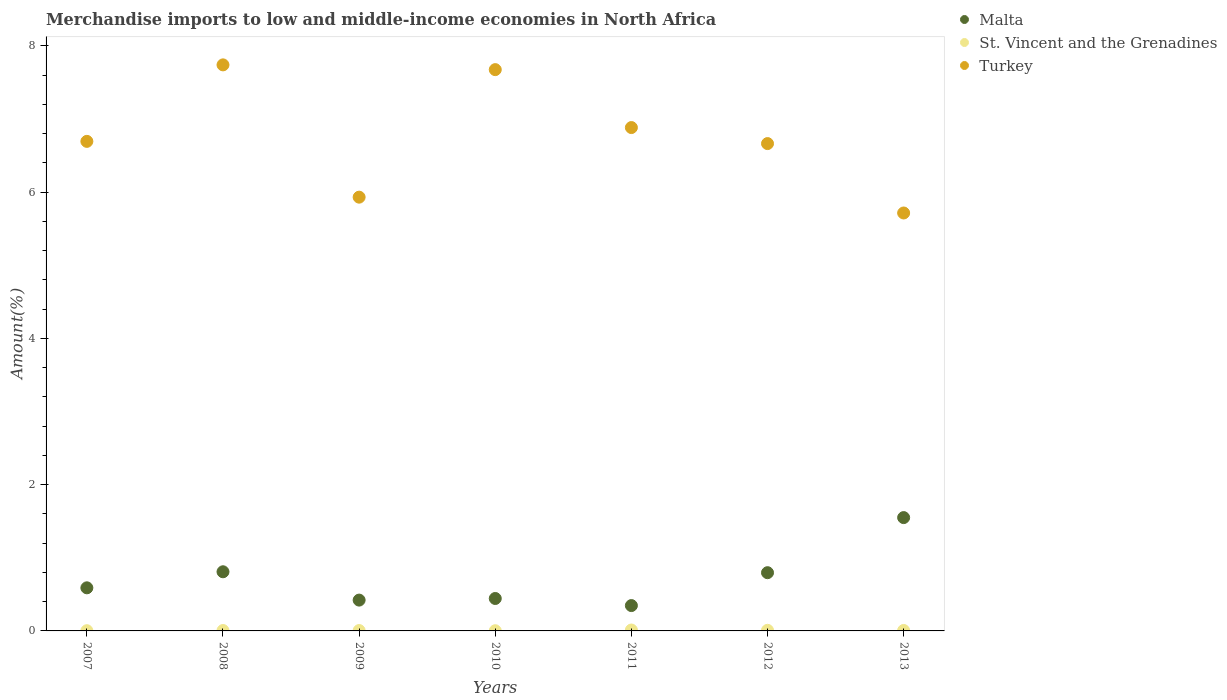How many different coloured dotlines are there?
Provide a short and direct response. 3. What is the percentage of amount earned from merchandise imports in Malta in 2010?
Make the answer very short. 0.44. Across all years, what is the maximum percentage of amount earned from merchandise imports in St. Vincent and the Grenadines?
Provide a short and direct response. 0.01. Across all years, what is the minimum percentage of amount earned from merchandise imports in Turkey?
Keep it short and to the point. 5.71. In which year was the percentage of amount earned from merchandise imports in Malta maximum?
Ensure brevity in your answer.  2013. What is the total percentage of amount earned from merchandise imports in Malta in the graph?
Provide a succinct answer. 4.96. What is the difference between the percentage of amount earned from merchandise imports in St. Vincent and the Grenadines in 2012 and that in 2013?
Make the answer very short. 0. What is the difference between the percentage of amount earned from merchandise imports in Malta in 2012 and the percentage of amount earned from merchandise imports in St. Vincent and the Grenadines in 2010?
Offer a terse response. 0.79. What is the average percentage of amount earned from merchandise imports in St. Vincent and the Grenadines per year?
Your answer should be very brief. 0.01. In the year 2013, what is the difference between the percentage of amount earned from merchandise imports in St. Vincent and the Grenadines and percentage of amount earned from merchandise imports in Malta?
Provide a succinct answer. -1.54. In how many years, is the percentage of amount earned from merchandise imports in St. Vincent and the Grenadines greater than 2.4 %?
Your answer should be very brief. 0. What is the ratio of the percentage of amount earned from merchandise imports in Turkey in 2008 to that in 2012?
Your answer should be compact. 1.16. Is the percentage of amount earned from merchandise imports in St. Vincent and the Grenadines in 2007 less than that in 2008?
Make the answer very short. Yes. Is the difference between the percentage of amount earned from merchandise imports in St. Vincent and the Grenadines in 2008 and 2012 greater than the difference between the percentage of amount earned from merchandise imports in Malta in 2008 and 2012?
Give a very brief answer. No. What is the difference between the highest and the second highest percentage of amount earned from merchandise imports in St. Vincent and the Grenadines?
Keep it short and to the point. 0. What is the difference between the highest and the lowest percentage of amount earned from merchandise imports in St. Vincent and the Grenadines?
Your answer should be very brief. 0.01. Is it the case that in every year, the sum of the percentage of amount earned from merchandise imports in Turkey and percentage of amount earned from merchandise imports in Malta  is greater than the percentage of amount earned from merchandise imports in St. Vincent and the Grenadines?
Provide a succinct answer. Yes. Is the percentage of amount earned from merchandise imports in Malta strictly greater than the percentage of amount earned from merchandise imports in St. Vincent and the Grenadines over the years?
Your answer should be very brief. Yes. How many dotlines are there?
Make the answer very short. 3. How many years are there in the graph?
Give a very brief answer. 7. What is the difference between two consecutive major ticks on the Y-axis?
Make the answer very short. 2. Does the graph contain any zero values?
Your answer should be compact. No. Does the graph contain grids?
Your response must be concise. No. What is the title of the graph?
Ensure brevity in your answer.  Merchandise imports to low and middle-income economies in North Africa. What is the label or title of the Y-axis?
Your answer should be very brief. Amount(%). What is the Amount(%) in Malta in 2007?
Ensure brevity in your answer.  0.59. What is the Amount(%) in St. Vincent and the Grenadines in 2007?
Provide a short and direct response. 0. What is the Amount(%) of Turkey in 2007?
Keep it short and to the point. 6.69. What is the Amount(%) of Malta in 2008?
Keep it short and to the point. 0.81. What is the Amount(%) of St. Vincent and the Grenadines in 2008?
Offer a terse response. 0.01. What is the Amount(%) of Turkey in 2008?
Provide a succinct answer. 7.74. What is the Amount(%) in Malta in 2009?
Keep it short and to the point. 0.42. What is the Amount(%) of St. Vincent and the Grenadines in 2009?
Offer a terse response. 0.01. What is the Amount(%) in Turkey in 2009?
Offer a very short reply. 5.93. What is the Amount(%) of Malta in 2010?
Ensure brevity in your answer.  0.44. What is the Amount(%) in St. Vincent and the Grenadines in 2010?
Offer a very short reply. 0. What is the Amount(%) of Turkey in 2010?
Give a very brief answer. 7.68. What is the Amount(%) of Malta in 2011?
Offer a terse response. 0.35. What is the Amount(%) of St. Vincent and the Grenadines in 2011?
Your answer should be compact. 0.01. What is the Amount(%) in Turkey in 2011?
Offer a very short reply. 6.88. What is the Amount(%) in Malta in 2012?
Your response must be concise. 0.8. What is the Amount(%) in St. Vincent and the Grenadines in 2012?
Provide a succinct answer. 0.01. What is the Amount(%) in Turkey in 2012?
Provide a short and direct response. 6.66. What is the Amount(%) of Malta in 2013?
Your answer should be very brief. 1.55. What is the Amount(%) of St. Vincent and the Grenadines in 2013?
Your answer should be compact. 0.01. What is the Amount(%) of Turkey in 2013?
Your answer should be very brief. 5.71. Across all years, what is the maximum Amount(%) of Malta?
Your answer should be compact. 1.55. Across all years, what is the maximum Amount(%) of St. Vincent and the Grenadines?
Make the answer very short. 0.01. Across all years, what is the maximum Amount(%) in Turkey?
Your answer should be very brief. 7.74. Across all years, what is the minimum Amount(%) of Malta?
Provide a short and direct response. 0.35. Across all years, what is the minimum Amount(%) of St. Vincent and the Grenadines?
Your response must be concise. 0. Across all years, what is the minimum Amount(%) of Turkey?
Provide a succinct answer. 5.71. What is the total Amount(%) of Malta in the graph?
Make the answer very short. 4.96. What is the total Amount(%) in St. Vincent and the Grenadines in the graph?
Make the answer very short. 0.04. What is the total Amount(%) of Turkey in the graph?
Your answer should be compact. 47.3. What is the difference between the Amount(%) of Malta in 2007 and that in 2008?
Keep it short and to the point. -0.22. What is the difference between the Amount(%) of St. Vincent and the Grenadines in 2007 and that in 2008?
Provide a short and direct response. -0. What is the difference between the Amount(%) of Turkey in 2007 and that in 2008?
Keep it short and to the point. -1.05. What is the difference between the Amount(%) in Malta in 2007 and that in 2009?
Offer a very short reply. 0.17. What is the difference between the Amount(%) in St. Vincent and the Grenadines in 2007 and that in 2009?
Offer a terse response. -0. What is the difference between the Amount(%) in Turkey in 2007 and that in 2009?
Offer a very short reply. 0.76. What is the difference between the Amount(%) in Malta in 2007 and that in 2010?
Offer a terse response. 0.15. What is the difference between the Amount(%) of St. Vincent and the Grenadines in 2007 and that in 2010?
Offer a very short reply. 0. What is the difference between the Amount(%) in Turkey in 2007 and that in 2010?
Provide a succinct answer. -0.98. What is the difference between the Amount(%) of Malta in 2007 and that in 2011?
Ensure brevity in your answer.  0.24. What is the difference between the Amount(%) in St. Vincent and the Grenadines in 2007 and that in 2011?
Give a very brief answer. -0.01. What is the difference between the Amount(%) of Turkey in 2007 and that in 2011?
Your answer should be compact. -0.19. What is the difference between the Amount(%) of Malta in 2007 and that in 2012?
Your answer should be very brief. -0.21. What is the difference between the Amount(%) of St. Vincent and the Grenadines in 2007 and that in 2012?
Your answer should be very brief. -0.01. What is the difference between the Amount(%) of Turkey in 2007 and that in 2012?
Your answer should be compact. 0.03. What is the difference between the Amount(%) of Malta in 2007 and that in 2013?
Make the answer very short. -0.96. What is the difference between the Amount(%) in St. Vincent and the Grenadines in 2007 and that in 2013?
Your answer should be very brief. -0. What is the difference between the Amount(%) of Turkey in 2007 and that in 2013?
Keep it short and to the point. 0.98. What is the difference between the Amount(%) of Malta in 2008 and that in 2009?
Provide a short and direct response. 0.39. What is the difference between the Amount(%) in St. Vincent and the Grenadines in 2008 and that in 2009?
Your answer should be very brief. 0. What is the difference between the Amount(%) in Turkey in 2008 and that in 2009?
Provide a short and direct response. 1.81. What is the difference between the Amount(%) of Malta in 2008 and that in 2010?
Provide a succinct answer. 0.37. What is the difference between the Amount(%) of St. Vincent and the Grenadines in 2008 and that in 2010?
Offer a very short reply. 0. What is the difference between the Amount(%) in Turkey in 2008 and that in 2010?
Make the answer very short. 0.07. What is the difference between the Amount(%) in Malta in 2008 and that in 2011?
Offer a terse response. 0.46. What is the difference between the Amount(%) of St. Vincent and the Grenadines in 2008 and that in 2011?
Provide a succinct answer. -0.01. What is the difference between the Amount(%) of Turkey in 2008 and that in 2011?
Your answer should be compact. 0.86. What is the difference between the Amount(%) of Malta in 2008 and that in 2012?
Make the answer very short. 0.01. What is the difference between the Amount(%) in St. Vincent and the Grenadines in 2008 and that in 2012?
Provide a short and direct response. -0. What is the difference between the Amount(%) in Turkey in 2008 and that in 2012?
Offer a very short reply. 1.08. What is the difference between the Amount(%) of Malta in 2008 and that in 2013?
Your answer should be compact. -0.74. What is the difference between the Amount(%) in St. Vincent and the Grenadines in 2008 and that in 2013?
Provide a short and direct response. -0. What is the difference between the Amount(%) in Turkey in 2008 and that in 2013?
Provide a short and direct response. 2.03. What is the difference between the Amount(%) in Malta in 2009 and that in 2010?
Your answer should be very brief. -0.02. What is the difference between the Amount(%) in St. Vincent and the Grenadines in 2009 and that in 2010?
Provide a succinct answer. 0. What is the difference between the Amount(%) in Turkey in 2009 and that in 2010?
Offer a terse response. -1.74. What is the difference between the Amount(%) of Malta in 2009 and that in 2011?
Keep it short and to the point. 0.07. What is the difference between the Amount(%) in St. Vincent and the Grenadines in 2009 and that in 2011?
Your answer should be compact. -0.01. What is the difference between the Amount(%) in Turkey in 2009 and that in 2011?
Provide a short and direct response. -0.95. What is the difference between the Amount(%) of Malta in 2009 and that in 2012?
Your response must be concise. -0.37. What is the difference between the Amount(%) of St. Vincent and the Grenadines in 2009 and that in 2012?
Give a very brief answer. -0. What is the difference between the Amount(%) of Turkey in 2009 and that in 2012?
Your answer should be very brief. -0.73. What is the difference between the Amount(%) in Malta in 2009 and that in 2013?
Offer a terse response. -1.13. What is the difference between the Amount(%) of St. Vincent and the Grenadines in 2009 and that in 2013?
Provide a short and direct response. -0. What is the difference between the Amount(%) in Turkey in 2009 and that in 2013?
Offer a terse response. 0.22. What is the difference between the Amount(%) in Malta in 2010 and that in 2011?
Make the answer very short. 0.1. What is the difference between the Amount(%) in St. Vincent and the Grenadines in 2010 and that in 2011?
Offer a very short reply. -0.01. What is the difference between the Amount(%) of Turkey in 2010 and that in 2011?
Your answer should be compact. 0.79. What is the difference between the Amount(%) in Malta in 2010 and that in 2012?
Ensure brevity in your answer.  -0.35. What is the difference between the Amount(%) of St. Vincent and the Grenadines in 2010 and that in 2012?
Your answer should be compact. -0.01. What is the difference between the Amount(%) in Turkey in 2010 and that in 2012?
Provide a succinct answer. 1.01. What is the difference between the Amount(%) in Malta in 2010 and that in 2013?
Give a very brief answer. -1.11. What is the difference between the Amount(%) in St. Vincent and the Grenadines in 2010 and that in 2013?
Give a very brief answer. -0. What is the difference between the Amount(%) in Turkey in 2010 and that in 2013?
Offer a very short reply. 1.96. What is the difference between the Amount(%) in Malta in 2011 and that in 2012?
Your response must be concise. -0.45. What is the difference between the Amount(%) in St. Vincent and the Grenadines in 2011 and that in 2012?
Your answer should be compact. 0. What is the difference between the Amount(%) of Turkey in 2011 and that in 2012?
Offer a terse response. 0.22. What is the difference between the Amount(%) of Malta in 2011 and that in 2013?
Ensure brevity in your answer.  -1.2. What is the difference between the Amount(%) in St. Vincent and the Grenadines in 2011 and that in 2013?
Ensure brevity in your answer.  0.01. What is the difference between the Amount(%) of Turkey in 2011 and that in 2013?
Offer a very short reply. 1.17. What is the difference between the Amount(%) in Malta in 2012 and that in 2013?
Provide a short and direct response. -0.75. What is the difference between the Amount(%) in St. Vincent and the Grenadines in 2012 and that in 2013?
Provide a succinct answer. 0. What is the difference between the Amount(%) of Turkey in 2012 and that in 2013?
Your answer should be compact. 0.95. What is the difference between the Amount(%) in Malta in 2007 and the Amount(%) in St. Vincent and the Grenadines in 2008?
Offer a very short reply. 0.58. What is the difference between the Amount(%) in Malta in 2007 and the Amount(%) in Turkey in 2008?
Offer a terse response. -7.15. What is the difference between the Amount(%) of St. Vincent and the Grenadines in 2007 and the Amount(%) of Turkey in 2008?
Offer a terse response. -7.74. What is the difference between the Amount(%) in Malta in 2007 and the Amount(%) in St. Vincent and the Grenadines in 2009?
Make the answer very short. 0.58. What is the difference between the Amount(%) of Malta in 2007 and the Amount(%) of Turkey in 2009?
Keep it short and to the point. -5.34. What is the difference between the Amount(%) of St. Vincent and the Grenadines in 2007 and the Amount(%) of Turkey in 2009?
Your answer should be very brief. -5.93. What is the difference between the Amount(%) in Malta in 2007 and the Amount(%) in St. Vincent and the Grenadines in 2010?
Your response must be concise. 0.59. What is the difference between the Amount(%) of Malta in 2007 and the Amount(%) of Turkey in 2010?
Offer a very short reply. -7.09. What is the difference between the Amount(%) of St. Vincent and the Grenadines in 2007 and the Amount(%) of Turkey in 2010?
Keep it short and to the point. -7.67. What is the difference between the Amount(%) of Malta in 2007 and the Amount(%) of St. Vincent and the Grenadines in 2011?
Keep it short and to the point. 0.58. What is the difference between the Amount(%) of Malta in 2007 and the Amount(%) of Turkey in 2011?
Make the answer very short. -6.29. What is the difference between the Amount(%) of St. Vincent and the Grenadines in 2007 and the Amount(%) of Turkey in 2011?
Give a very brief answer. -6.88. What is the difference between the Amount(%) in Malta in 2007 and the Amount(%) in St. Vincent and the Grenadines in 2012?
Offer a very short reply. 0.58. What is the difference between the Amount(%) in Malta in 2007 and the Amount(%) in Turkey in 2012?
Offer a terse response. -6.07. What is the difference between the Amount(%) of St. Vincent and the Grenadines in 2007 and the Amount(%) of Turkey in 2012?
Give a very brief answer. -6.66. What is the difference between the Amount(%) in Malta in 2007 and the Amount(%) in St. Vincent and the Grenadines in 2013?
Your answer should be compact. 0.58. What is the difference between the Amount(%) of Malta in 2007 and the Amount(%) of Turkey in 2013?
Provide a short and direct response. -5.13. What is the difference between the Amount(%) of St. Vincent and the Grenadines in 2007 and the Amount(%) of Turkey in 2013?
Offer a very short reply. -5.71. What is the difference between the Amount(%) of Malta in 2008 and the Amount(%) of St. Vincent and the Grenadines in 2009?
Provide a short and direct response. 0.8. What is the difference between the Amount(%) of Malta in 2008 and the Amount(%) of Turkey in 2009?
Offer a very short reply. -5.12. What is the difference between the Amount(%) in St. Vincent and the Grenadines in 2008 and the Amount(%) in Turkey in 2009?
Your answer should be very brief. -5.93. What is the difference between the Amount(%) of Malta in 2008 and the Amount(%) of St. Vincent and the Grenadines in 2010?
Ensure brevity in your answer.  0.81. What is the difference between the Amount(%) in Malta in 2008 and the Amount(%) in Turkey in 2010?
Offer a very short reply. -6.87. What is the difference between the Amount(%) of St. Vincent and the Grenadines in 2008 and the Amount(%) of Turkey in 2010?
Offer a terse response. -7.67. What is the difference between the Amount(%) in Malta in 2008 and the Amount(%) in St. Vincent and the Grenadines in 2011?
Ensure brevity in your answer.  0.8. What is the difference between the Amount(%) of Malta in 2008 and the Amount(%) of Turkey in 2011?
Ensure brevity in your answer.  -6.07. What is the difference between the Amount(%) in St. Vincent and the Grenadines in 2008 and the Amount(%) in Turkey in 2011?
Provide a succinct answer. -6.88. What is the difference between the Amount(%) of Malta in 2008 and the Amount(%) of St. Vincent and the Grenadines in 2012?
Give a very brief answer. 0.8. What is the difference between the Amount(%) of Malta in 2008 and the Amount(%) of Turkey in 2012?
Offer a very short reply. -5.86. What is the difference between the Amount(%) of St. Vincent and the Grenadines in 2008 and the Amount(%) of Turkey in 2012?
Your response must be concise. -6.66. What is the difference between the Amount(%) in Malta in 2008 and the Amount(%) in St. Vincent and the Grenadines in 2013?
Make the answer very short. 0.8. What is the difference between the Amount(%) in Malta in 2008 and the Amount(%) in Turkey in 2013?
Your answer should be very brief. -4.91. What is the difference between the Amount(%) of St. Vincent and the Grenadines in 2008 and the Amount(%) of Turkey in 2013?
Make the answer very short. -5.71. What is the difference between the Amount(%) in Malta in 2009 and the Amount(%) in St. Vincent and the Grenadines in 2010?
Ensure brevity in your answer.  0.42. What is the difference between the Amount(%) in Malta in 2009 and the Amount(%) in Turkey in 2010?
Offer a very short reply. -7.25. What is the difference between the Amount(%) in St. Vincent and the Grenadines in 2009 and the Amount(%) in Turkey in 2010?
Provide a short and direct response. -7.67. What is the difference between the Amount(%) of Malta in 2009 and the Amount(%) of St. Vincent and the Grenadines in 2011?
Give a very brief answer. 0.41. What is the difference between the Amount(%) in Malta in 2009 and the Amount(%) in Turkey in 2011?
Ensure brevity in your answer.  -6.46. What is the difference between the Amount(%) in St. Vincent and the Grenadines in 2009 and the Amount(%) in Turkey in 2011?
Your answer should be compact. -6.88. What is the difference between the Amount(%) of Malta in 2009 and the Amount(%) of St. Vincent and the Grenadines in 2012?
Give a very brief answer. 0.41. What is the difference between the Amount(%) in Malta in 2009 and the Amount(%) in Turkey in 2012?
Ensure brevity in your answer.  -6.24. What is the difference between the Amount(%) in St. Vincent and the Grenadines in 2009 and the Amount(%) in Turkey in 2012?
Provide a short and direct response. -6.66. What is the difference between the Amount(%) in Malta in 2009 and the Amount(%) in St. Vincent and the Grenadines in 2013?
Your answer should be very brief. 0.42. What is the difference between the Amount(%) of Malta in 2009 and the Amount(%) of Turkey in 2013?
Your answer should be very brief. -5.29. What is the difference between the Amount(%) in St. Vincent and the Grenadines in 2009 and the Amount(%) in Turkey in 2013?
Give a very brief answer. -5.71. What is the difference between the Amount(%) of Malta in 2010 and the Amount(%) of St. Vincent and the Grenadines in 2011?
Keep it short and to the point. 0.43. What is the difference between the Amount(%) in Malta in 2010 and the Amount(%) in Turkey in 2011?
Ensure brevity in your answer.  -6.44. What is the difference between the Amount(%) of St. Vincent and the Grenadines in 2010 and the Amount(%) of Turkey in 2011?
Give a very brief answer. -6.88. What is the difference between the Amount(%) in Malta in 2010 and the Amount(%) in St. Vincent and the Grenadines in 2012?
Keep it short and to the point. 0.43. What is the difference between the Amount(%) in Malta in 2010 and the Amount(%) in Turkey in 2012?
Your answer should be very brief. -6.22. What is the difference between the Amount(%) of St. Vincent and the Grenadines in 2010 and the Amount(%) of Turkey in 2012?
Ensure brevity in your answer.  -6.66. What is the difference between the Amount(%) in Malta in 2010 and the Amount(%) in St. Vincent and the Grenadines in 2013?
Your answer should be compact. 0.44. What is the difference between the Amount(%) in Malta in 2010 and the Amount(%) in Turkey in 2013?
Offer a very short reply. -5.27. What is the difference between the Amount(%) in St. Vincent and the Grenadines in 2010 and the Amount(%) in Turkey in 2013?
Provide a short and direct response. -5.71. What is the difference between the Amount(%) in Malta in 2011 and the Amount(%) in St. Vincent and the Grenadines in 2012?
Ensure brevity in your answer.  0.34. What is the difference between the Amount(%) of Malta in 2011 and the Amount(%) of Turkey in 2012?
Your answer should be compact. -6.32. What is the difference between the Amount(%) in St. Vincent and the Grenadines in 2011 and the Amount(%) in Turkey in 2012?
Your response must be concise. -6.65. What is the difference between the Amount(%) of Malta in 2011 and the Amount(%) of St. Vincent and the Grenadines in 2013?
Offer a very short reply. 0.34. What is the difference between the Amount(%) of Malta in 2011 and the Amount(%) of Turkey in 2013?
Your answer should be compact. -5.37. What is the difference between the Amount(%) in St. Vincent and the Grenadines in 2011 and the Amount(%) in Turkey in 2013?
Make the answer very short. -5.7. What is the difference between the Amount(%) in Malta in 2012 and the Amount(%) in St. Vincent and the Grenadines in 2013?
Ensure brevity in your answer.  0.79. What is the difference between the Amount(%) of Malta in 2012 and the Amount(%) of Turkey in 2013?
Your answer should be very brief. -4.92. What is the difference between the Amount(%) of St. Vincent and the Grenadines in 2012 and the Amount(%) of Turkey in 2013?
Offer a terse response. -5.71. What is the average Amount(%) in Malta per year?
Your answer should be very brief. 0.71. What is the average Amount(%) of St. Vincent and the Grenadines per year?
Your answer should be very brief. 0.01. What is the average Amount(%) in Turkey per year?
Offer a terse response. 6.76. In the year 2007, what is the difference between the Amount(%) in Malta and Amount(%) in St. Vincent and the Grenadines?
Your response must be concise. 0.59. In the year 2007, what is the difference between the Amount(%) of Malta and Amount(%) of Turkey?
Give a very brief answer. -6.1. In the year 2007, what is the difference between the Amount(%) of St. Vincent and the Grenadines and Amount(%) of Turkey?
Provide a succinct answer. -6.69. In the year 2008, what is the difference between the Amount(%) of Malta and Amount(%) of St. Vincent and the Grenadines?
Provide a short and direct response. 0.8. In the year 2008, what is the difference between the Amount(%) of Malta and Amount(%) of Turkey?
Keep it short and to the point. -6.93. In the year 2008, what is the difference between the Amount(%) of St. Vincent and the Grenadines and Amount(%) of Turkey?
Provide a short and direct response. -7.73. In the year 2009, what is the difference between the Amount(%) of Malta and Amount(%) of St. Vincent and the Grenadines?
Ensure brevity in your answer.  0.42. In the year 2009, what is the difference between the Amount(%) in Malta and Amount(%) in Turkey?
Ensure brevity in your answer.  -5.51. In the year 2009, what is the difference between the Amount(%) of St. Vincent and the Grenadines and Amount(%) of Turkey?
Make the answer very short. -5.93. In the year 2010, what is the difference between the Amount(%) of Malta and Amount(%) of St. Vincent and the Grenadines?
Give a very brief answer. 0.44. In the year 2010, what is the difference between the Amount(%) of Malta and Amount(%) of Turkey?
Provide a short and direct response. -7.23. In the year 2010, what is the difference between the Amount(%) in St. Vincent and the Grenadines and Amount(%) in Turkey?
Offer a very short reply. -7.67. In the year 2011, what is the difference between the Amount(%) in Malta and Amount(%) in St. Vincent and the Grenadines?
Provide a short and direct response. 0.33. In the year 2011, what is the difference between the Amount(%) in Malta and Amount(%) in Turkey?
Keep it short and to the point. -6.54. In the year 2011, what is the difference between the Amount(%) in St. Vincent and the Grenadines and Amount(%) in Turkey?
Give a very brief answer. -6.87. In the year 2012, what is the difference between the Amount(%) of Malta and Amount(%) of St. Vincent and the Grenadines?
Offer a very short reply. 0.79. In the year 2012, what is the difference between the Amount(%) in Malta and Amount(%) in Turkey?
Offer a terse response. -5.87. In the year 2012, what is the difference between the Amount(%) of St. Vincent and the Grenadines and Amount(%) of Turkey?
Provide a succinct answer. -6.66. In the year 2013, what is the difference between the Amount(%) of Malta and Amount(%) of St. Vincent and the Grenadines?
Give a very brief answer. 1.54. In the year 2013, what is the difference between the Amount(%) of Malta and Amount(%) of Turkey?
Keep it short and to the point. -4.17. In the year 2013, what is the difference between the Amount(%) in St. Vincent and the Grenadines and Amount(%) in Turkey?
Your answer should be compact. -5.71. What is the ratio of the Amount(%) of Malta in 2007 to that in 2008?
Provide a succinct answer. 0.73. What is the ratio of the Amount(%) of St. Vincent and the Grenadines in 2007 to that in 2008?
Provide a succinct answer. 0.57. What is the ratio of the Amount(%) of Turkey in 2007 to that in 2008?
Your response must be concise. 0.86. What is the ratio of the Amount(%) in Malta in 2007 to that in 2009?
Ensure brevity in your answer.  1.4. What is the ratio of the Amount(%) of St. Vincent and the Grenadines in 2007 to that in 2009?
Make the answer very short. 0.59. What is the ratio of the Amount(%) in Turkey in 2007 to that in 2009?
Your answer should be very brief. 1.13. What is the ratio of the Amount(%) in Malta in 2007 to that in 2010?
Provide a succinct answer. 1.33. What is the ratio of the Amount(%) in St. Vincent and the Grenadines in 2007 to that in 2010?
Ensure brevity in your answer.  1.16. What is the ratio of the Amount(%) of Turkey in 2007 to that in 2010?
Your response must be concise. 0.87. What is the ratio of the Amount(%) of Malta in 2007 to that in 2011?
Your answer should be compact. 1.7. What is the ratio of the Amount(%) of St. Vincent and the Grenadines in 2007 to that in 2011?
Provide a short and direct response. 0.25. What is the ratio of the Amount(%) in Turkey in 2007 to that in 2011?
Your response must be concise. 0.97. What is the ratio of the Amount(%) of Malta in 2007 to that in 2012?
Give a very brief answer. 0.74. What is the ratio of the Amount(%) of St. Vincent and the Grenadines in 2007 to that in 2012?
Give a very brief answer. 0.36. What is the ratio of the Amount(%) of Malta in 2007 to that in 2013?
Your answer should be compact. 0.38. What is the ratio of the Amount(%) of St. Vincent and the Grenadines in 2007 to that in 2013?
Your response must be concise. 0.5. What is the ratio of the Amount(%) of Turkey in 2007 to that in 2013?
Provide a short and direct response. 1.17. What is the ratio of the Amount(%) in Malta in 2008 to that in 2009?
Give a very brief answer. 1.92. What is the ratio of the Amount(%) of St. Vincent and the Grenadines in 2008 to that in 2009?
Keep it short and to the point. 1.04. What is the ratio of the Amount(%) of Turkey in 2008 to that in 2009?
Offer a very short reply. 1.3. What is the ratio of the Amount(%) of Malta in 2008 to that in 2010?
Your response must be concise. 1.82. What is the ratio of the Amount(%) of St. Vincent and the Grenadines in 2008 to that in 2010?
Your answer should be compact. 2.06. What is the ratio of the Amount(%) in Turkey in 2008 to that in 2010?
Your answer should be compact. 1.01. What is the ratio of the Amount(%) of Malta in 2008 to that in 2011?
Ensure brevity in your answer.  2.33. What is the ratio of the Amount(%) in St. Vincent and the Grenadines in 2008 to that in 2011?
Provide a short and direct response. 0.44. What is the ratio of the Amount(%) in Turkey in 2008 to that in 2011?
Keep it short and to the point. 1.12. What is the ratio of the Amount(%) of Malta in 2008 to that in 2012?
Your response must be concise. 1.02. What is the ratio of the Amount(%) in St. Vincent and the Grenadines in 2008 to that in 2012?
Give a very brief answer. 0.64. What is the ratio of the Amount(%) in Turkey in 2008 to that in 2012?
Your answer should be compact. 1.16. What is the ratio of the Amount(%) of Malta in 2008 to that in 2013?
Provide a succinct answer. 0.52. What is the ratio of the Amount(%) of St. Vincent and the Grenadines in 2008 to that in 2013?
Make the answer very short. 0.88. What is the ratio of the Amount(%) of Turkey in 2008 to that in 2013?
Ensure brevity in your answer.  1.35. What is the ratio of the Amount(%) of Malta in 2009 to that in 2010?
Provide a succinct answer. 0.95. What is the ratio of the Amount(%) of St. Vincent and the Grenadines in 2009 to that in 2010?
Provide a short and direct response. 1.98. What is the ratio of the Amount(%) of Turkey in 2009 to that in 2010?
Your answer should be compact. 0.77. What is the ratio of the Amount(%) of Malta in 2009 to that in 2011?
Offer a very short reply. 1.22. What is the ratio of the Amount(%) in St. Vincent and the Grenadines in 2009 to that in 2011?
Offer a terse response. 0.43. What is the ratio of the Amount(%) of Turkey in 2009 to that in 2011?
Your response must be concise. 0.86. What is the ratio of the Amount(%) in Malta in 2009 to that in 2012?
Provide a succinct answer. 0.53. What is the ratio of the Amount(%) in St. Vincent and the Grenadines in 2009 to that in 2012?
Offer a terse response. 0.62. What is the ratio of the Amount(%) of Turkey in 2009 to that in 2012?
Your response must be concise. 0.89. What is the ratio of the Amount(%) in Malta in 2009 to that in 2013?
Offer a very short reply. 0.27. What is the ratio of the Amount(%) in St. Vincent and the Grenadines in 2009 to that in 2013?
Provide a succinct answer. 0.85. What is the ratio of the Amount(%) of Turkey in 2009 to that in 2013?
Make the answer very short. 1.04. What is the ratio of the Amount(%) in Malta in 2010 to that in 2011?
Ensure brevity in your answer.  1.28. What is the ratio of the Amount(%) in St. Vincent and the Grenadines in 2010 to that in 2011?
Your response must be concise. 0.22. What is the ratio of the Amount(%) in Turkey in 2010 to that in 2011?
Keep it short and to the point. 1.12. What is the ratio of the Amount(%) of Malta in 2010 to that in 2012?
Keep it short and to the point. 0.56. What is the ratio of the Amount(%) of St. Vincent and the Grenadines in 2010 to that in 2012?
Provide a short and direct response. 0.31. What is the ratio of the Amount(%) in Turkey in 2010 to that in 2012?
Your answer should be very brief. 1.15. What is the ratio of the Amount(%) of Malta in 2010 to that in 2013?
Offer a terse response. 0.29. What is the ratio of the Amount(%) of St. Vincent and the Grenadines in 2010 to that in 2013?
Your answer should be compact. 0.43. What is the ratio of the Amount(%) in Turkey in 2010 to that in 2013?
Your response must be concise. 1.34. What is the ratio of the Amount(%) in Malta in 2011 to that in 2012?
Offer a very short reply. 0.44. What is the ratio of the Amount(%) in St. Vincent and the Grenadines in 2011 to that in 2012?
Offer a terse response. 1.45. What is the ratio of the Amount(%) in Turkey in 2011 to that in 2012?
Give a very brief answer. 1.03. What is the ratio of the Amount(%) of Malta in 2011 to that in 2013?
Make the answer very short. 0.22. What is the ratio of the Amount(%) in St. Vincent and the Grenadines in 2011 to that in 2013?
Give a very brief answer. 1.98. What is the ratio of the Amount(%) of Turkey in 2011 to that in 2013?
Make the answer very short. 1.2. What is the ratio of the Amount(%) in Malta in 2012 to that in 2013?
Ensure brevity in your answer.  0.51. What is the ratio of the Amount(%) of St. Vincent and the Grenadines in 2012 to that in 2013?
Your answer should be very brief. 1.37. What is the ratio of the Amount(%) in Turkey in 2012 to that in 2013?
Provide a succinct answer. 1.17. What is the difference between the highest and the second highest Amount(%) in Malta?
Keep it short and to the point. 0.74. What is the difference between the highest and the second highest Amount(%) in St. Vincent and the Grenadines?
Ensure brevity in your answer.  0. What is the difference between the highest and the second highest Amount(%) in Turkey?
Make the answer very short. 0.07. What is the difference between the highest and the lowest Amount(%) in Malta?
Make the answer very short. 1.2. What is the difference between the highest and the lowest Amount(%) in St. Vincent and the Grenadines?
Keep it short and to the point. 0.01. What is the difference between the highest and the lowest Amount(%) in Turkey?
Ensure brevity in your answer.  2.03. 